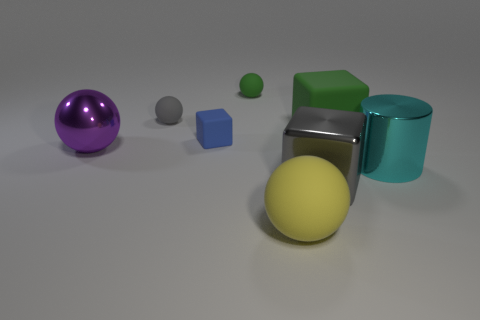There is a matte thing that is both in front of the large green matte thing and left of the tiny green rubber object; what color is it?
Give a very brief answer. Blue. There is a gray thing that is behind the big matte thing that is behind the small thing in front of the big green matte object; how big is it?
Your answer should be compact. Small. How many objects are either objects behind the yellow ball or balls that are behind the gray rubber object?
Offer a very short reply. 7. What is the shape of the small gray object?
Your answer should be compact. Sphere. What number of other objects are there of the same material as the green block?
Provide a short and direct response. 4. There is a gray metal thing that is the same shape as the small blue object; what size is it?
Offer a terse response. Large. What material is the green object that is right of the big block that is in front of the big object behind the purple sphere?
Offer a terse response. Rubber. Are any small green shiny things visible?
Offer a terse response. No. There is a large metal cylinder; does it have the same color as the rubber cube on the left side of the large yellow matte thing?
Your answer should be very brief. No. The big rubber ball has what color?
Your answer should be compact. Yellow. 